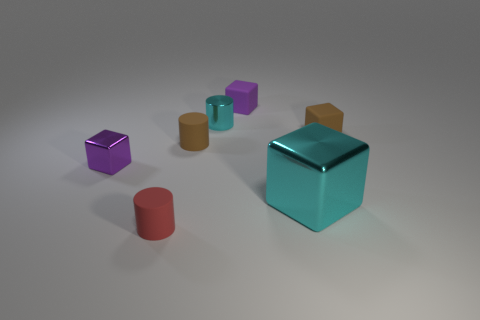Are there any other things that are the same size as the cyan metallic block?
Your answer should be very brief. No. What color is the thing that is left of the large shiny thing and in front of the small purple shiny cube?
Provide a short and direct response. Red. Do the small block behind the brown matte block and the tiny brown thing that is to the right of the small purple rubber object have the same material?
Your response must be concise. Yes. Is the number of small red things in front of the cyan cube greater than the number of tiny matte things in front of the red matte cylinder?
Offer a very short reply. Yes. There is a metallic thing that is the same size as the purple shiny block; what shape is it?
Make the answer very short. Cylinder. How many objects are big purple objects or purple cubes on the right side of the small red rubber thing?
Your answer should be compact. 1. Does the big object have the same color as the metal cylinder?
Provide a short and direct response. Yes. How many large blocks are behind the tiny purple matte thing?
Your response must be concise. 0. What color is the other cylinder that is made of the same material as the small red cylinder?
Offer a very short reply. Brown. What number of rubber objects are red things or cyan cubes?
Provide a succinct answer. 1. 